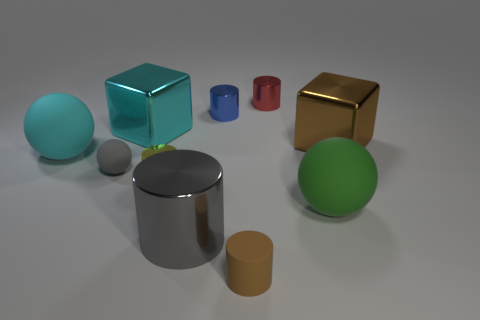There is a large metal thing to the left of the big gray object; is it the same shape as the gray matte object?
Give a very brief answer. No. Is there a large cyan object that has the same shape as the small red object?
Offer a terse response. No. There is a large object that is the same color as the small matte ball; what is it made of?
Keep it short and to the point. Metal. The small rubber thing to the right of the tiny blue thing that is in front of the tiny red shiny object is what shape?
Offer a very short reply. Cylinder. How many big green spheres have the same material as the large green thing?
Your answer should be compact. 0. There is another big block that is made of the same material as the large cyan cube; what is its color?
Give a very brief answer. Brown. There is a cyan object that is to the left of the big shiny block on the left side of the sphere that is right of the brown cylinder; what size is it?
Offer a very short reply. Large. Are there fewer small yellow shiny cylinders than tiny green cylinders?
Make the answer very short. No. What is the color of the other large object that is the same shape as the big brown thing?
Offer a very short reply. Cyan. There is a large cyan thing that is behind the big ball on the left side of the small yellow thing; is there a small object that is behind it?
Offer a terse response. Yes. 